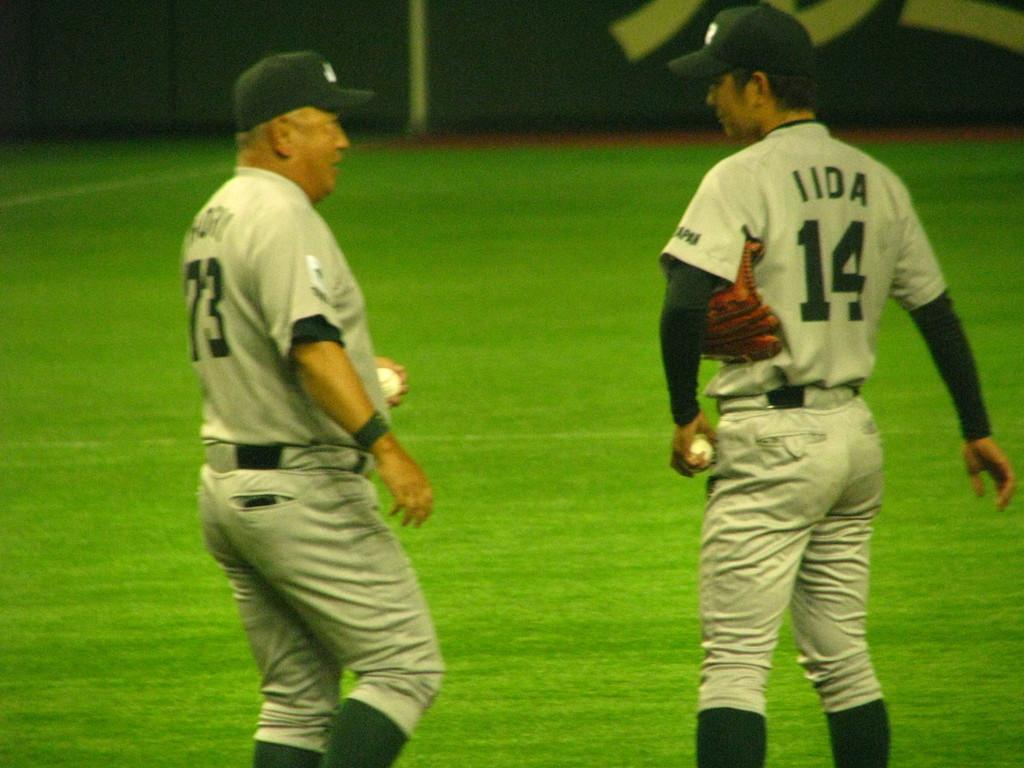Provide a one-sentence caption for the provided image. Player number 14 speaks to man with number 73. 